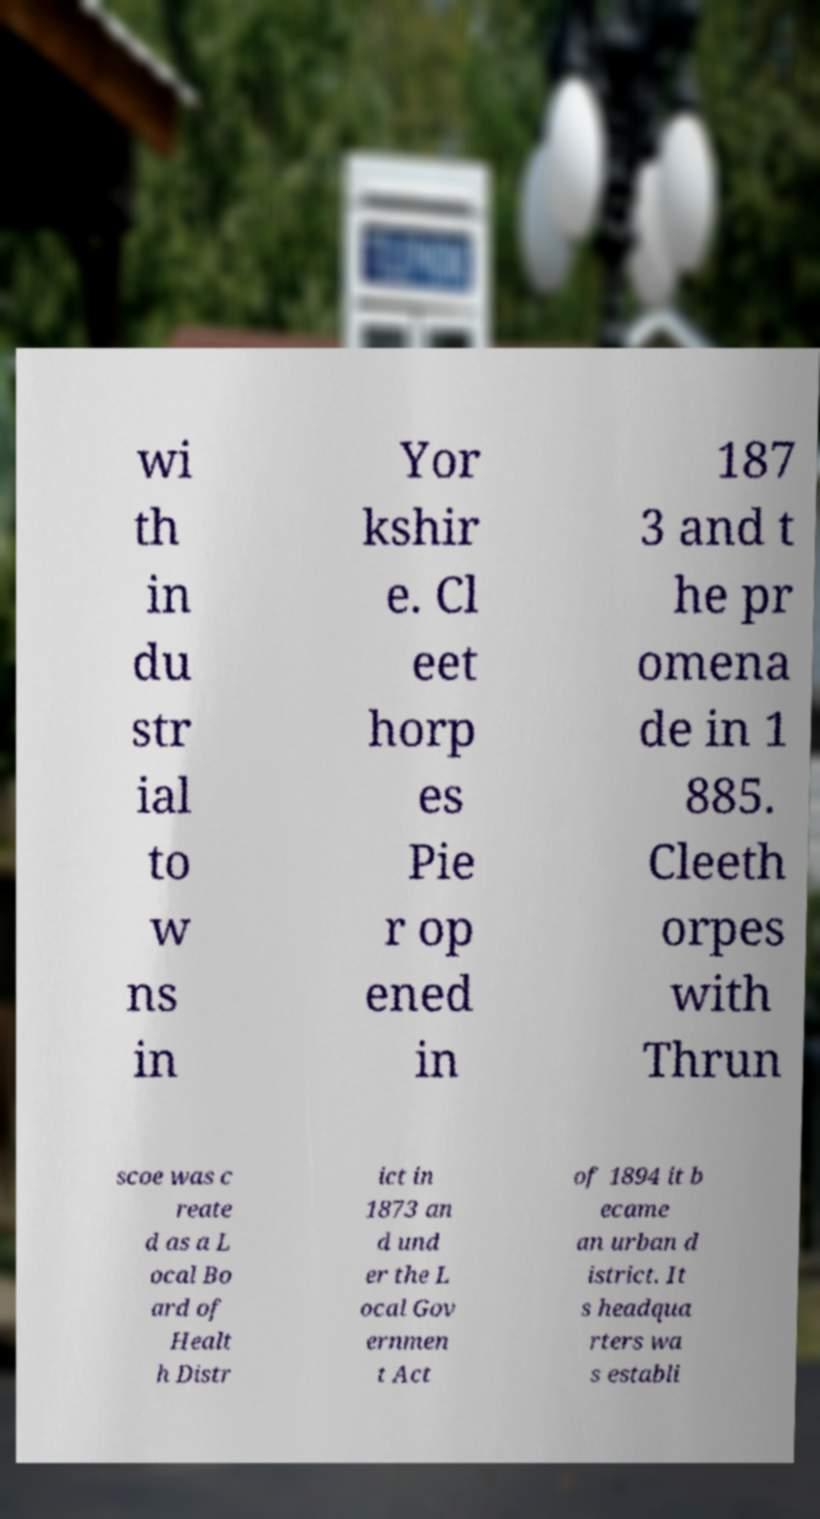Could you extract and type out the text from this image? wi th in du str ial to w ns in Yor kshir e. Cl eet horp es Pie r op ened in 187 3 and t he pr omena de in 1 885. Cleeth orpes with Thrun scoe was c reate d as a L ocal Bo ard of Healt h Distr ict in 1873 an d und er the L ocal Gov ernmen t Act of 1894 it b ecame an urban d istrict. It s headqua rters wa s establi 